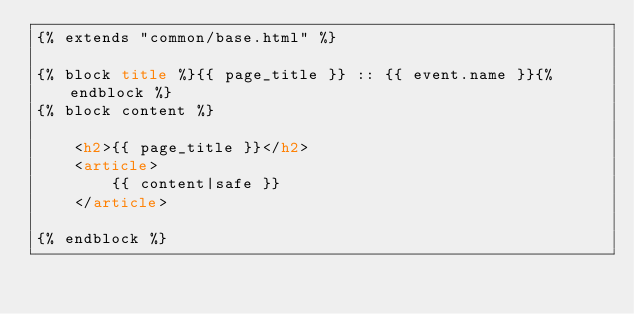<code> <loc_0><loc_0><loc_500><loc_500><_HTML_>{% extends "common/base.html" %}

{% block title %}{{ page_title }} :: {{ event.name }}{% endblock %}
{% block content %}

    <h2>{{ page_title }}</h2>
    <article>
        {{ content|safe }}
    </article>

{% endblock %}
</code> 